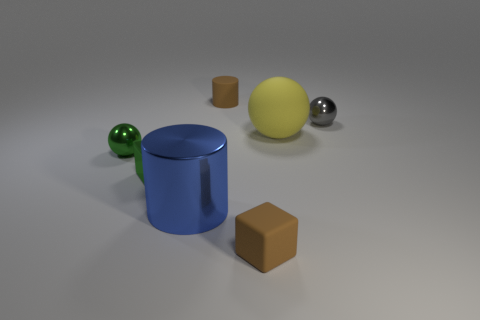Subtract all metal spheres. How many spheres are left? 1 Subtract all gray spheres. How many spheres are left? 2 Add 2 small gray balls. How many objects exist? 9 Subtract 1 cubes. How many cubes are left? 1 Add 7 tiny gray shiny things. How many tiny gray shiny things are left? 8 Add 4 tiny green blocks. How many tiny green blocks exist? 5 Subtract 1 green blocks. How many objects are left? 6 Subtract all spheres. How many objects are left? 4 Subtract all cyan cylinders. Subtract all yellow cubes. How many cylinders are left? 2 Subtract all green cubes. How many yellow balls are left? 1 